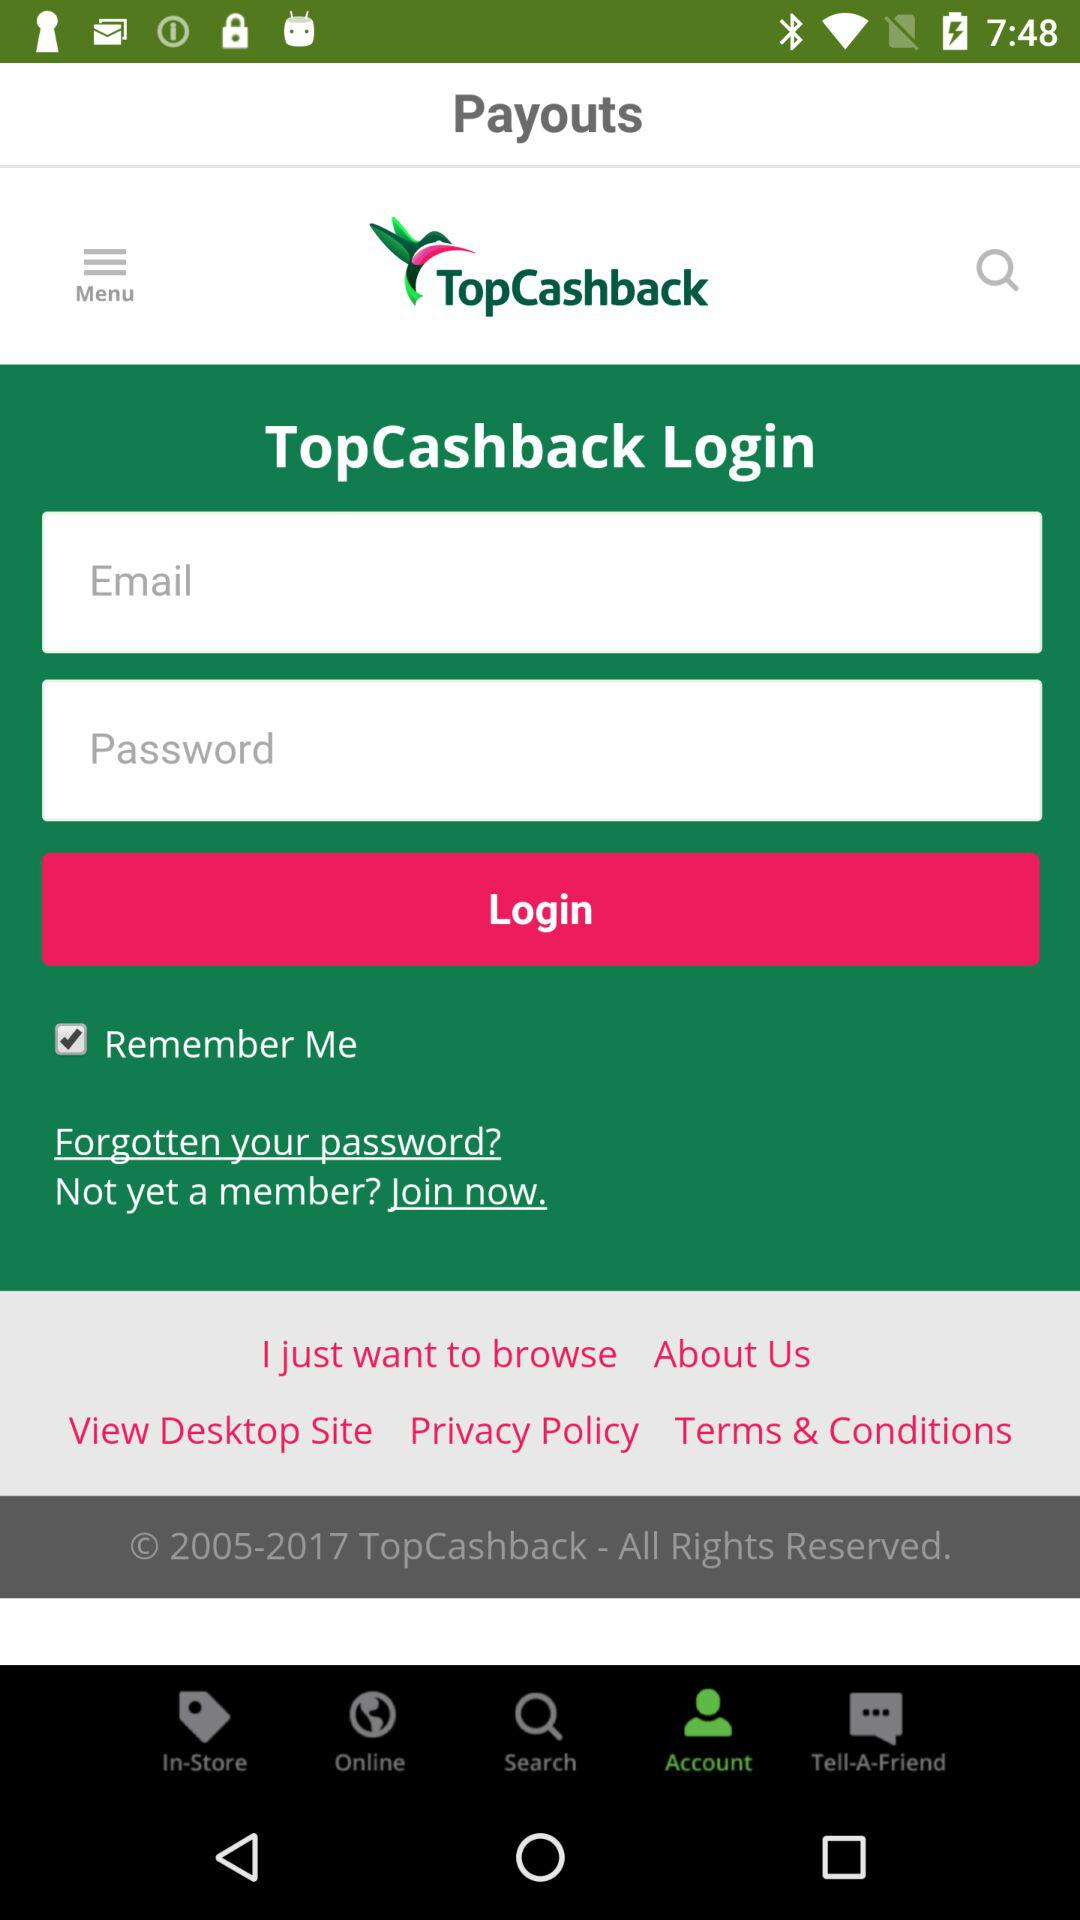Which button is selected?
When the provided information is insufficient, respond with <no answer>. <no answer> 